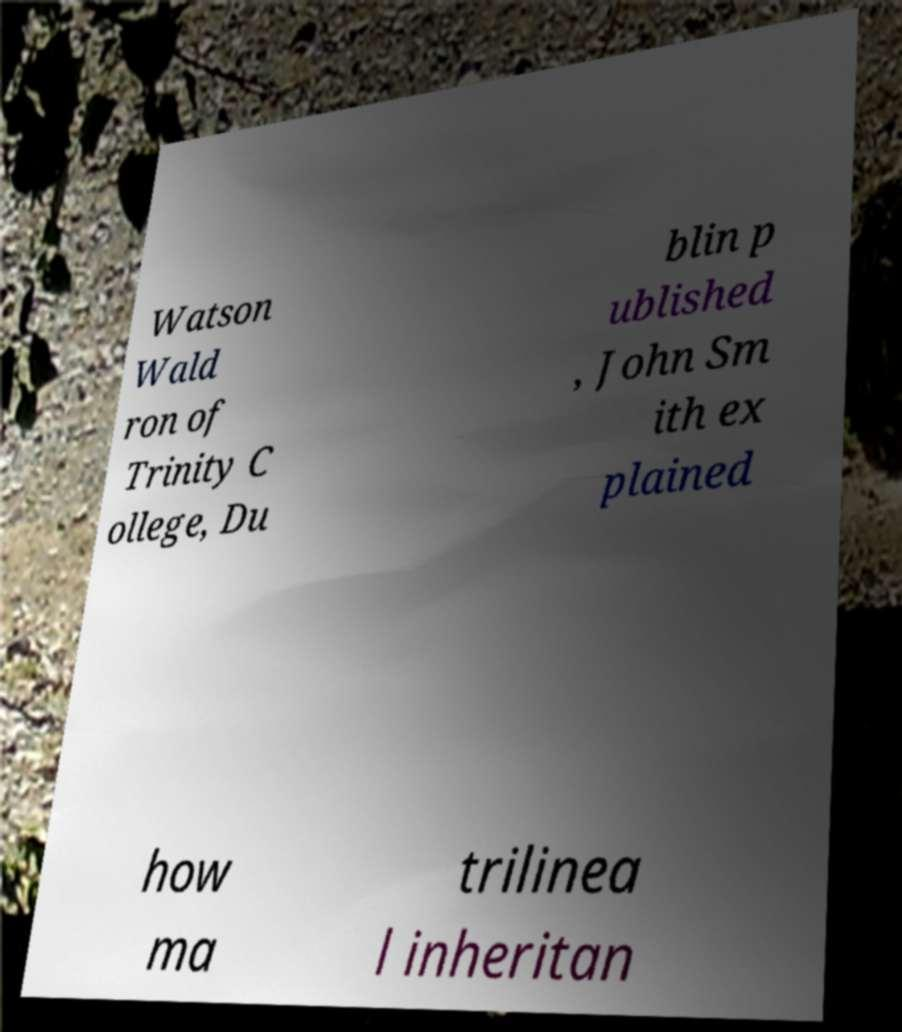There's text embedded in this image that I need extracted. Can you transcribe it verbatim? Watson Wald ron of Trinity C ollege, Du blin p ublished , John Sm ith ex plained how ma trilinea l inheritan 